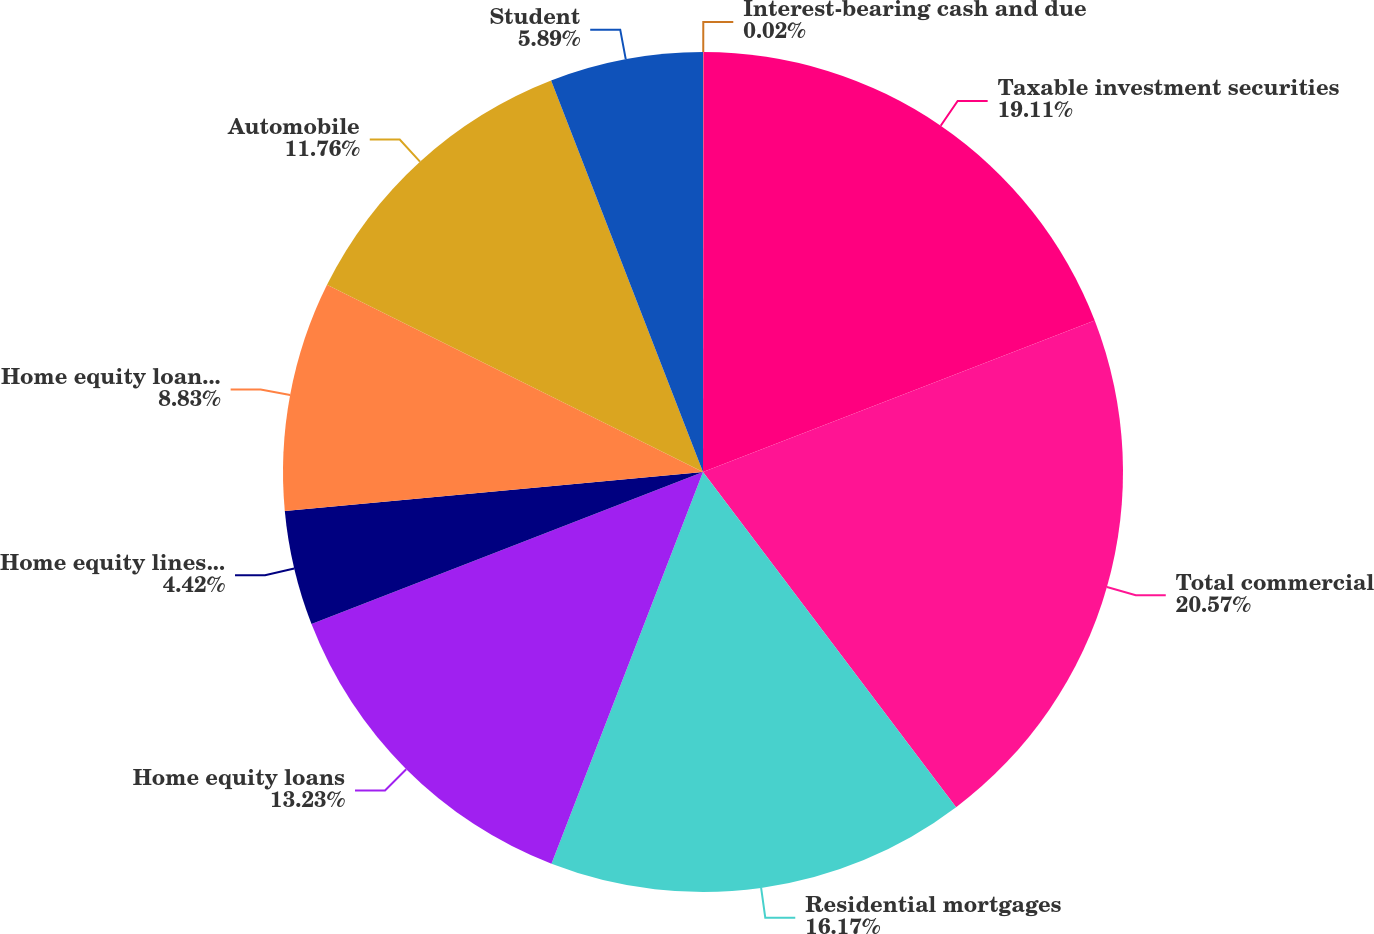<chart> <loc_0><loc_0><loc_500><loc_500><pie_chart><fcel>Interest-bearing cash and due<fcel>Taxable investment securities<fcel>Total commercial<fcel>Residential mortgages<fcel>Home equity loans<fcel>Home equity lines of credit<fcel>Home equity loans serviced by<fcel>Automobile<fcel>Student<nl><fcel>0.02%<fcel>19.11%<fcel>20.58%<fcel>16.17%<fcel>13.23%<fcel>4.42%<fcel>8.83%<fcel>11.76%<fcel>5.89%<nl></chart> 